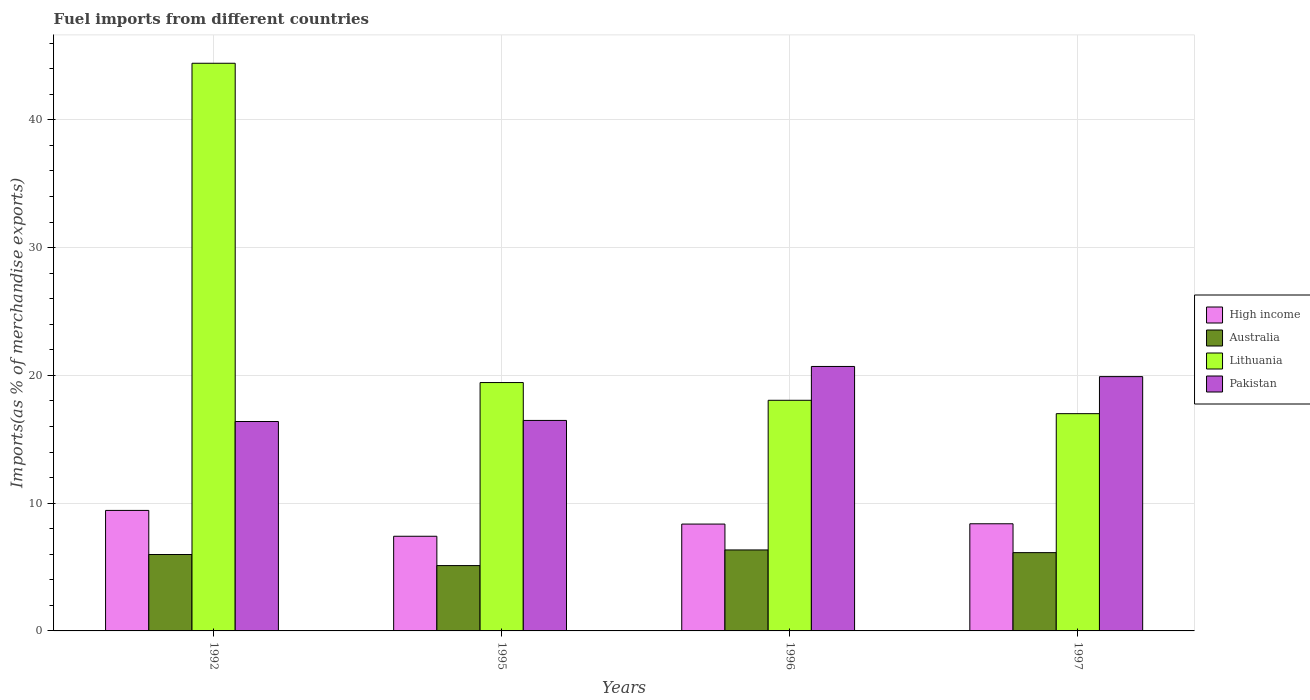Are the number of bars on each tick of the X-axis equal?
Offer a very short reply. Yes. What is the label of the 3rd group of bars from the left?
Make the answer very short. 1996. What is the percentage of imports to different countries in High income in 1992?
Offer a very short reply. 9.43. Across all years, what is the maximum percentage of imports to different countries in High income?
Make the answer very short. 9.43. Across all years, what is the minimum percentage of imports to different countries in High income?
Ensure brevity in your answer.  7.41. In which year was the percentage of imports to different countries in Pakistan minimum?
Offer a terse response. 1992. What is the total percentage of imports to different countries in Pakistan in the graph?
Your response must be concise. 73.47. What is the difference between the percentage of imports to different countries in Lithuania in 1992 and that in 1997?
Keep it short and to the point. 27.43. What is the difference between the percentage of imports to different countries in Lithuania in 1997 and the percentage of imports to different countries in Pakistan in 1995?
Your response must be concise. 0.53. What is the average percentage of imports to different countries in Lithuania per year?
Your answer should be compact. 24.73. In the year 1996, what is the difference between the percentage of imports to different countries in Lithuania and percentage of imports to different countries in Pakistan?
Offer a terse response. -2.65. In how many years, is the percentage of imports to different countries in Australia greater than 30 %?
Give a very brief answer. 0. What is the ratio of the percentage of imports to different countries in High income in 1996 to that in 1997?
Your response must be concise. 1. Is the percentage of imports to different countries in Pakistan in 1995 less than that in 1997?
Keep it short and to the point. Yes. Is the difference between the percentage of imports to different countries in Lithuania in 1992 and 1996 greater than the difference between the percentage of imports to different countries in Pakistan in 1992 and 1996?
Your answer should be compact. Yes. What is the difference between the highest and the second highest percentage of imports to different countries in Australia?
Provide a succinct answer. 0.21. What is the difference between the highest and the lowest percentage of imports to different countries in Australia?
Ensure brevity in your answer.  1.23. In how many years, is the percentage of imports to different countries in High income greater than the average percentage of imports to different countries in High income taken over all years?
Offer a very short reply. 1. What does the 3rd bar from the left in 1992 represents?
Offer a very short reply. Lithuania. What does the 3rd bar from the right in 1995 represents?
Make the answer very short. Australia. Is it the case that in every year, the sum of the percentage of imports to different countries in Lithuania and percentage of imports to different countries in Australia is greater than the percentage of imports to different countries in Pakistan?
Your response must be concise. Yes. How many bars are there?
Offer a terse response. 16. Are all the bars in the graph horizontal?
Keep it short and to the point. No. What is the difference between two consecutive major ticks on the Y-axis?
Keep it short and to the point. 10. Are the values on the major ticks of Y-axis written in scientific E-notation?
Your answer should be very brief. No. Does the graph contain any zero values?
Provide a short and direct response. No. Does the graph contain grids?
Keep it short and to the point. Yes. How many legend labels are there?
Your answer should be compact. 4. How are the legend labels stacked?
Keep it short and to the point. Vertical. What is the title of the graph?
Ensure brevity in your answer.  Fuel imports from different countries. Does "Seychelles" appear as one of the legend labels in the graph?
Keep it short and to the point. No. What is the label or title of the Y-axis?
Your answer should be very brief. Imports(as % of merchandise exports). What is the Imports(as % of merchandise exports) of High income in 1992?
Your answer should be very brief. 9.43. What is the Imports(as % of merchandise exports) of Australia in 1992?
Offer a terse response. 5.98. What is the Imports(as % of merchandise exports) of Lithuania in 1992?
Your response must be concise. 44.43. What is the Imports(as % of merchandise exports) of Pakistan in 1992?
Offer a terse response. 16.39. What is the Imports(as % of merchandise exports) in High income in 1995?
Provide a succinct answer. 7.41. What is the Imports(as % of merchandise exports) in Australia in 1995?
Ensure brevity in your answer.  5.11. What is the Imports(as % of merchandise exports) of Lithuania in 1995?
Provide a short and direct response. 19.44. What is the Imports(as % of merchandise exports) of Pakistan in 1995?
Ensure brevity in your answer.  16.47. What is the Imports(as % of merchandise exports) in High income in 1996?
Make the answer very short. 8.36. What is the Imports(as % of merchandise exports) of Australia in 1996?
Make the answer very short. 6.34. What is the Imports(as % of merchandise exports) in Lithuania in 1996?
Offer a terse response. 18.05. What is the Imports(as % of merchandise exports) of Pakistan in 1996?
Make the answer very short. 20.7. What is the Imports(as % of merchandise exports) of High income in 1997?
Your answer should be compact. 8.39. What is the Imports(as % of merchandise exports) in Australia in 1997?
Offer a terse response. 6.13. What is the Imports(as % of merchandise exports) of Lithuania in 1997?
Provide a short and direct response. 17. What is the Imports(as % of merchandise exports) of Pakistan in 1997?
Offer a very short reply. 19.9. Across all years, what is the maximum Imports(as % of merchandise exports) in High income?
Keep it short and to the point. 9.43. Across all years, what is the maximum Imports(as % of merchandise exports) in Australia?
Your answer should be very brief. 6.34. Across all years, what is the maximum Imports(as % of merchandise exports) in Lithuania?
Your response must be concise. 44.43. Across all years, what is the maximum Imports(as % of merchandise exports) in Pakistan?
Your answer should be very brief. 20.7. Across all years, what is the minimum Imports(as % of merchandise exports) in High income?
Keep it short and to the point. 7.41. Across all years, what is the minimum Imports(as % of merchandise exports) in Australia?
Offer a terse response. 5.11. Across all years, what is the minimum Imports(as % of merchandise exports) in Lithuania?
Offer a very short reply. 17. Across all years, what is the minimum Imports(as % of merchandise exports) of Pakistan?
Give a very brief answer. 16.39. What is the total Imports(as % of merchandise exports) in High income in the graph?
Provide a succinct answer. 33.59. What is the total Imports(as % of merchandise exports) of Australia in the graph?
Give a very brief answer. 23.56. What is the total Imports(as % of merchandise exports) of Lithuania in the graph?
Provide a succinct answer. 98.93. What is the total Imports(as % of merchandise exports) of Pakistan in the graph?
Ensure brevity in your answer.  73.47. What is the difference between the Imports(as % of merchandise exports) in High income in 1992 and that in 1995?
Make the answer very short. 2.02. What is the difference between the Imports(as % of merchandise exports) in Australia in 1992 and that in 1995?
Give a very brief answer. 0.87. What is the difference between the Imports(as % of merchandise exports) in Lithuania in 1992 and that in 1995?
Offer a terse response. 24.99. What is the difference between the Imports(as % of merchandise exports) in Pakistan in 1992 and that in 1995?
Provide a short and direct response. -0.08. What is the difference between the Imports(as % of merchandise exports) in High income in 1992 and that in 1996?
Provide a succinct answer. 1.07. What is the difference between the Imports(as % of merchandise exports) in Australia in 1992 and that in 1996?
Your answer should be compact. -0.36. What is the difference between the Imports(as % of merchandise exports) of Lithuania in 1992 and that in 1996?
Your response must be concise. 26.38. What is the difference between the Imports(as % of merchandise exports) in Pakistan in 1992 and that in 1996?
Give a very brief answer. -4.31. What is the difference between the Imports(as % of merchandise exports) in High income in 1992 and that in 1997?
Offer a very short reply. 1.05. What is the difference between the Imports(as % of merchandise exports) in Australia in 1992 and that in 1997?
Provide a succinct answer. -0.15. What is the difference between the Imports(as % of merchandise exports) in Lithuania in 1992 and that in 1997?
Keep it short and to the point. 27.43. What is the difference between the Imports(as % of merchandise exports) in Pakistan in 1992 and that in 1997?
Offer a terse response. -3.51. What is the difference between the Imports(as % of merchandise exports) in High income in 1995 and that in 1996?
Provide a succinct answer. -0.95. What is the difference between the Imports(as % of merchandise exports) of Australia in 1995 and that in 1996?
Your response must be concise. -1.23. What is the difference between the Imports(as % of merchandise exports) in Lithuania in 1995 and that in 1996?
Your answer should be very brief. 1.39. What is the difference between the Imports(as % of merchandise exports) of Pakistan in 1995 and that in 1996?
Your answer should be very brief. -4.23. What is the difference between the Imports(as % of merchandise exports) in High income in 1995 and that in 1997?
Ensure brevity in your answer.  -0.98. What is the difference between the Imports(as % of merchandise exports) of Australia in 1995 and that in 1997?
Give a very brief answer. -1.01. What is the difference between the Imports(as % of merchandise exports) in Lithuania in 1995 and that in 1997?
Make the answer very short. 2.44. What is the difference between the Imports(as % of merchandise exports) of Pakistan in 1995 and that in 1997?
Ensure brevity in your answer.  -3.43. What is the difference between the Imports(as % of merchandise exports) in High income in 1996 and that in 1997?
Provide a succinct answer. -0.02. What is the difference between the Imports(as % of merchandise exports) of Australia in 1996 and that in 1997?
Your answer should be compact. 0.21. What is the difference between the Imports(as % of merchandise exports) in Lithuania in 1996 and that in 1997?
Keep it short and to the point. 1.05. What is the difference between the Imports(as % of merchandise exports) in Pakistan in 1996 and that in 1997?
Offer a very short reply. 0.8. What is the difference between the Imports(as % of merchandise exports) in High income in 1992 and the Imports(as % of merchandise exports) in Australia in 1995?
Keep it short and to the point. 4.32. What is the difference between the Imports(as % of merchandise exports) in High income in 1992 and the Imports(as % of merchandise exports) in Lithuania in 1995?
Your answer should be very brief. -10.01. What is the difference between the Imports(as % of merchandise exports) in High income in 1992 and the Imports(as % of merchandise exports) in Pakistan in 1995?
Your answer should be very brief. -7.04. What is the difference between the Imports(as % of merchandise exports) in Australia in 1992 and the Imports(as % of merchandise exports) in Lithuania in 1995?
Offer a very short reply. -13.46. What is the difference between the Imports(as % of merchandise exports) of Australia in 1992 and the Imports(as % of merchandise exports) of Pakistan in 1995?
Offer a very short reply. -10.49. What is the difference between the Imports(as % of merchandise exports) in Lithuania in 1992 and the Imports(as % of merchandise exports) in Pakistan in 1995?
Ensure brevity in your answer.  27.96. What is the difference between the Imports(as % of merchandise exports) in High income in 1992 and the Imports(as % of merchandise exports) in Australia in 1996?
Your answer should be very brief. 3.09. What is the difference between the Imports(as % of merchandise exports) of High income in 1992 and the Imports(as % of merchandise exports) of Lithuania in 1996?
Provide a succinct answer. -8.62. What is the difference between the Imports(as % of merchandise exports) in High income in 1992 and the Imports(as % of merchandise exports) in Pakistan in 1996?
Offer a terse response. -11.27. What is the difference between the Imports(as % of merchandise exports) in Australia in 1992 and the Imports(as % of merchandise exports) in Lithuania in 1996?
Your answer should be compact. -12.07. What is the difference between the Imports(as % of merchandise exports) of Australia in 1992 and the Imports(as % of merchandise exports) of Pakistan in 1996?
Keep it short and to the point. -14.72. What is the difference between the Imports(as % of merchandise exports) in Lithuania in 1992 and the Imports(as % of merchandise exports) in Pakistan in 1996?
Your answer should be very brief. 23.73. What is the difference between the Imports(as % of merchandise exports) in High income in 1992 and the Imports(as % of merchandise exports) in Australia in 1997?
Offer a very short reply. 3.31. What is the difference between the Imports(as % of merchandise exports) in High income in 1992 and the Imports(as % of merchandise exports) in Lithuania in 1997?
Offer a very short reply. -7.57. What is the difference between the Imports(as % of merchandise exports) in High income in 1992 and the Imports(as % of merchandise exports) in Pakistan in 1997?
Your answer should be very brief. -10.47. What is the difference between the Imports(as % of merchandise exports) of Australia in 1992 and the Imports(as % of merchandise exports) of Lithuania in 1997?
Offer a terse response. -11.02. What is the difference between the Imports(as % of merchandise exports) in Australia in 1992 and the Imports(as % of merchandise exports) in Pakistan in 1997?
Keep it short and to the point. -13.92. What is the difference between the Imports(as % of merchandise exports) in Lithuania in 1992 and the Imports(as % of merchandise exports) in Pakistan in 1997?
Provide a short and direct response. 24.53. What is the difference between the Imports(as % of merchandise exports) in High income in 1995 and the Imports(as % of merchandise exports) in Australia in 1996?
Provide a succinct answer. 1.07. What is the difference between the Imports(as % of merchandise exports) of High income in 1995 and the Imports(as % of merchandise exports) of Lithuania in 1996?
Give a very brief answer. -10.64. What is the difference between the Imports(as % of merchandise exports) of High income in 1995 and the Imports(as % of merchandise exports) of Pakistan in 1996?
Offer a terse response. -13.29. What is the difference between the Imports(as % of merchandise exports) of Australia in 1995 and the Imports(as % of merchandise exports) of Lithuania in 1996?
Ensure brevity in your answer.  -12.94. What is the difference between the Imports(as % of merchandise exports) of Australia in 1995 and the Imports(as % of merchandise exports) of Pakistan in 1996?
Provide a succinct answer. -15.59. What is the difference between the Imports(as % of merchandise exports) in Lithuania in 1995 and the Imports(as % of merchandise exports) in Pakistan in 1996?
Keep it short and to the point. -1.26. What is the difference between the Imports(as % of merchandise exports) in High income in 1995 and the Imports(as % of merchandise exports) in Australia in 1997?
Offer a very short reply. 1.28. What is the difference between the Imports(as % of merchandise exports) in High income in 1995 and the Imports(as % of merchandise exports) in Lithuania in 1997?
Give a very brief answer. -9.6. What is the difference between the Imports(as % of merchandise exports) in High income in 1995 and the Imports(as % of merchandise exports) in Pakistan in 1997?
Your response must be concise. -12.49. What is the difference between the Imports(as % of merchandise exports) of Australia in 1995 and the Imports(as % of merchandise exports) of Lithuania in 1997?
Make the answer very short. -11.89. What is the difference between the Imports(as % of merchandise exports) of Australia in 1995 and the Imports(as % of merchandise exports) of Pakistan in 1997?
Make the answer very short. -14.79. What is the difference between the Imports(as % of merchandise exports) of Lithuania in 1995 and the Imports(as % of merchandise exports) of Pakistan in 1997?
Your response must be concise. -0.46. What is the difference between the Imports(as % of merchandise exports) in High income in 1996 and the Imports(as % of merchandise exports) in Australia in 1997?
Make the answer very short. 2.24. What is the difference between the Imports(as % of merchandise exports) of High income in 1996 and the Imports(as % of merchandise exports) of Lithuania in 1997?
Provide a succinct answer. -8.64. What is the difference between the Imports(as % of merchandise exports) in High income in 1996 and the Imports(as % of merchandise exports) in Pakistan in 1997?
Your answer should be very brief. -11.54. What is the difference between the Imports(as % of merchandise exports) in Australia in 1996 and the Imports(as % of merchandise exports) in Lithuania in 1997?
Offer a terse response. -10.67. What is the difference between the Imports(as % of merchandise exports) of Australia in 1996 and the Imports(as % of merchandise exports) of Pakistan in 1997?
Ensure brevity in your answer.  -13.57. What is the difference between the Imports(as % of merchandise exports) of Lithuania in 1996 and the Imports(as % of merchandise exports) of Pakistan in 1997?
Provide a succinct answer. -1.85. What is the average Imports(as % of merchandise exports) of High income per year?
Your answer should be compact. 8.4. What is the average Imports(as % of merchandise exports) in Australia per year?
Your answer should be very brief. 5.89. What is the average Imports(as % of merchandise exports) in Lithuania per year?
Keep it short and to the point. 24.73. What is the average Imports(as % of merchandise exports) of Pakistan per year?
Offer a very short reply. 18.37. In the year 1992, what is the difference between the Imports(as % of merchandise exports) in High income and Imports(as % of merchandise exports) in Australia?
Your answer should be very brief. 3.45. In the year 1992, what is the difference between the Imports(as % of merchandise exports) of High income and Imports(as % of merchandise exports) of Lithuania?
Offer a terse response. -35. In the year 1992, what is the difference between the Imports(as % of merchandise exports) of High income and Imports(as % of merchandise exports) of Pakistan?
Offer a very short reply. -6.96. In the year 1992, what is the difference between the Imports(as % of merchandise exports) in Australia and Imports(as % of merchandise exports) in Lithuania?
Give a very brief answer. -38.45. In the year 1992, what is the difference between the Imports(as % of merchandise exports) in Australia and Imports(as % of merchandise exports) in Pakistan?
Give a very brief answer. -10.41. In the year 1992, what is the difference between the Imports(as % of merchandise exports) of Lithuania and Imports(as % of merchandise exports) of Pakistan?
Provide a succinct answer. 28.04. In the year 1995, what is the difference between the Imports(as % of merchandise exports) of High income and Imports(as % of merchandise exports) of Australia?
Offer a terse response. 2.3. In the year 1995, what is the difference between the Imports(as % of merchandise exports) in High income and Imports(as % of merchandise exports) in Lithuania?
Give a very brief answer. -12.03. In the year 1995, what is the difference between the Imports(as % of merchandise exports) in High income and Imports(as % of merchandise exports) in Pakistan?
Give a very brief answer. -9.07. In the year 1995, what is the difference between the Imports(as % of merchandise exports) of Australia and Imports(as % of merchandise exports) of Lithuania?
Ensure brevity in your answer.  -14.33. In the year 1995, what is the difference between the Imports(as % of merchandise exports) of Australia and Imports(as % of merchandise exports) of Pakistan?
Offer a very short reply. -11.36. In the year 1995, what is the difference between the Imports(as % of merchandise exports) of Lithuania and Imports(as % of merchandise exports) of Pakistan?
Your answer should be very brief. 2.97. In the year 1996, what is the difference between the Imports(as % of merchandise exports) in High income and Imports(as % of merchandise exports) in Australia?
Provide a short and direct response. 2.03. In the year 1996, what is the difference between the Imports(as % of merchandise exports) of High income and Imports(as % of merchandise exports) of Lithuania?
Provide a succinct answer. -9.69. In the year 1996, what is the difference between the Imports(as % of merchandise exports) in High income and Imports(as % of merchandise exports) in Pakistan?
Your answer should be compact. -12.34. In the year 1996, what is the difference between the Imports(as % of merchandise exports) of Australia and Imports(as % of merchandise exports) of Lithuania?
Keep it short and to the point. -11.71. In the year 1996, what is the difference between the Imports(as % of merchandise exports) of Australia and Imports(as % of merchandise exports) of Pakistan?
Your answer should be very brief. -14.36. In the year 1996, what is the difference between the Imports(as % of merchandise exports) of Lithuania and Imports(as % of merchandise exports) of Pakistan?
Provide a succinct answer. -2.65. In the year 1997, what is the difference between the Imports(as % of merchandise exports) in High income and Imports(as % of merchandise exports) in Australia?
Provide a succinct answer. 2.26. In the year 1997, what is the difference between the Imports(as % of merchandise exports) in High income and Imports(as % of merchandise exports) in Lithuania?
Give a very brief answer. -8.62. In the year 1997, what is the difference between the Imports(as % of merchandise exports) of High income and Imports(as % of merchandise exports) of Pakistan?
Give a very brief answer. -11.52. In the year 1997, what is the difference between the Imports(as % of merchandise exports) in Australia and Imports(as % of merchandise exports) in Lithuania?
Offer a very short reply. -10.88. In the year 1997, what is the difference between the Imports(as % of merchandise exports) of Australia and Imports(as % of merchandise exports) of Pakistan?
Ensure brevity in your answer.  -13.78. In the year 1997, what is the difference between the Imports(as % of merchandise exports) of Lithuania and Imports(as % of merchandise exports) of Pakistan?
Ensure brevity in your answer.  -2.9. What is the ratio of the Imports(as % of merchandise exports) in High income in 1992 to that in 1995?
Give a very brief answer. 1.27. What is the ratio of the Imports(as % of merchandise exports) of Australia in 1992 to that in 1995?
Give a very brief answer. 1.17. What is the ratio of the Imports(as % of merchandise exports) in Lithuania in 1992 to that in 1995?
Make the answer very short. 2.29. What is the ratio of the Imports(as % of merchandise exports) in High income in 1992 to that in 1996?
Offer a very short reply. 1.13. What is the ratio of the Imports(as % of merchandise exports) in Australia in 1992 to that in 1996?
Your answer should be very brief. 0.94. What is the ratio of the Imports(as % of merchandise exports) in Lithuania in 1992 to that in 1996?
Ensure brevity in your answer.  2.46. What is the ratio of the Imports(as % of merchandise exports) of Pakistan in 1992 to that in 1996?
Offer a very short reply. 0.79. What is the ratio of the Imports(as % of merchandise exports) in High income in 1992 to that in 1997?
Your response must be concise. 1.12. What is the ratio of the Imports(as % of merchandise exports) of Lithuania in 1992 to that in 1997?
Make the answer very short. 2.61. What is the ratio of the Imports(as % of merchandise exports) in Pakistan in 1992 to that in 1997?
Your answer should be compact. 0.82. What is the ratio of the Imports(as % of merchandise exports) of High income in 1995 to that in 1996?
Your answer should be very brief. 0.89. What is the ratio of the Imports(as % of merchandise exports) of Australia in 1995 to that in 1996?
Your response must be concise. 0.81. What is the ratio of the Imports(as % of merchandise exports) of Pakistan in 1995 to that in 1996?
Your response must be concise. 0.8. What is the ratio of the Imports(as % of merchandise exports) in High income in 1995 to that in 1997?
Your answer should be compact. 0.88. What is the ratio of the Imports(as % of merchandise exports) of Australia in 1995 to that in 1997?
Your answer should be very brief. 0.83. What is the ratio of the Imports(as % of merchandise exports) in Lithuania in 1995 to that in 1997?
Keep it short and to the point. 1.14. What is the ratio of the Imports(as % of merchandise exports) of Pakistan in 1995 to that in 1997?
Your response must be concise. 0.83. What is the ratio of the Imports(as % of merchandise exports) of High income in 1996 to that in 1997?
Keep it short and to the point. 1. What is the ratio of the Imports(as % of merchandise exports) of Australia in 1996 to that in 1997?
Your response must be concise. 1.03. What is the ratio of the Imports(as % of merchandise exports) of Lithuania in 1996 to that in 1997?
Your answer should be compact. 1.06. What is the ratio of the Imports(as % of merchandise exports) of Pakistan in 1996 to that in 1997?
Offer a very short reply. 1.04. What is the difference between the highest and the second highest Imports(as % of merchandise exports) of High income?
Your answer should be very brief. 1.05. What is the difference between the highest and the second highest Imports(as % of merchandise exports) of Australia?
Provide a short and direct response. 0.21. What is the difference between the highest and the second highest Imports(as % of merchandise exports) in Lithuania?
Keep it short and to the point. 24.99. What is the difference between the highest and the second highest Imports(as % of merchandise exports) in Pakistan?
Offer a very short reply. 0.8. What is the difference between the highest and the lowest Imports(as % of merchandise exports) of High income?
Your response must be concise. 2.02. What is the difference between the highest and the lowest Imports(as % of merchandise exports) in Australia?
Your answer should be compact. 1.23. What is the difference between the highest and the lowest Imports(as % of merchandise exports) in Lithuania?
Provide a succinct answer. 27.43. What is the difference between the highest and the lowest Imports(as % of merchandise exports) of Pakistan?
Offer a terse response. 4.31. 